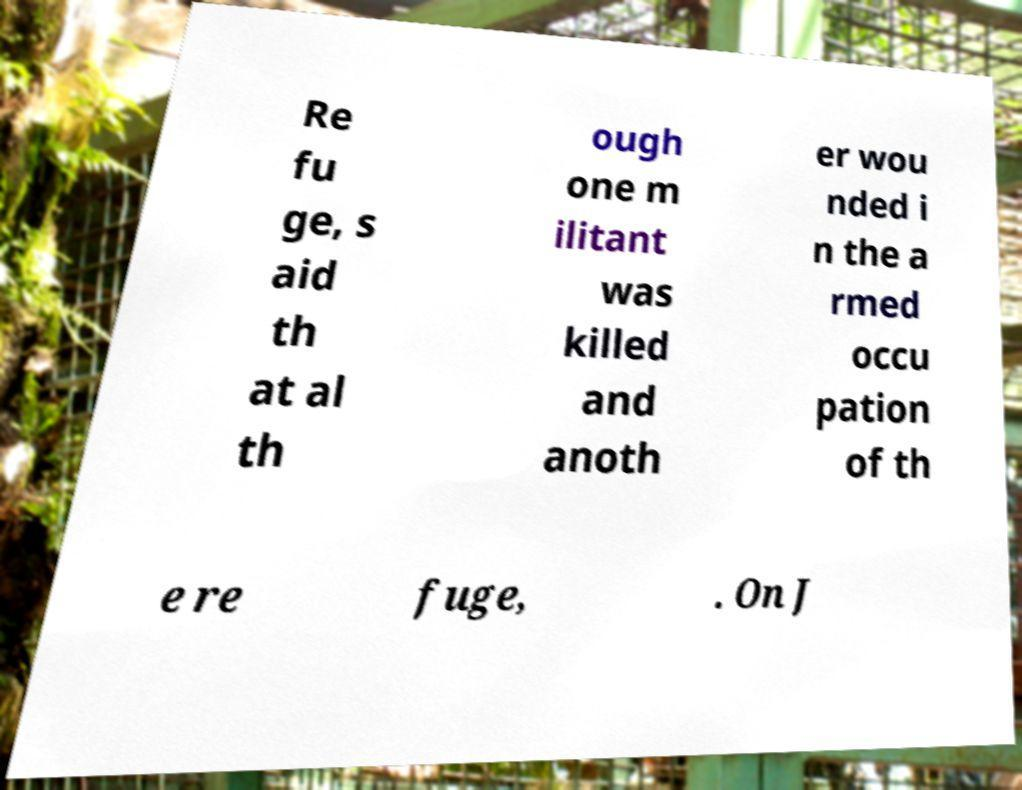There's text embedded in this image that I need extracted. Can you transcribe it verbatim? Re fu ge, s aid th at al th ough one m ilitant was killed and anoth er wou nded i n the a rmed occu pation of th e re fuge, . On J 